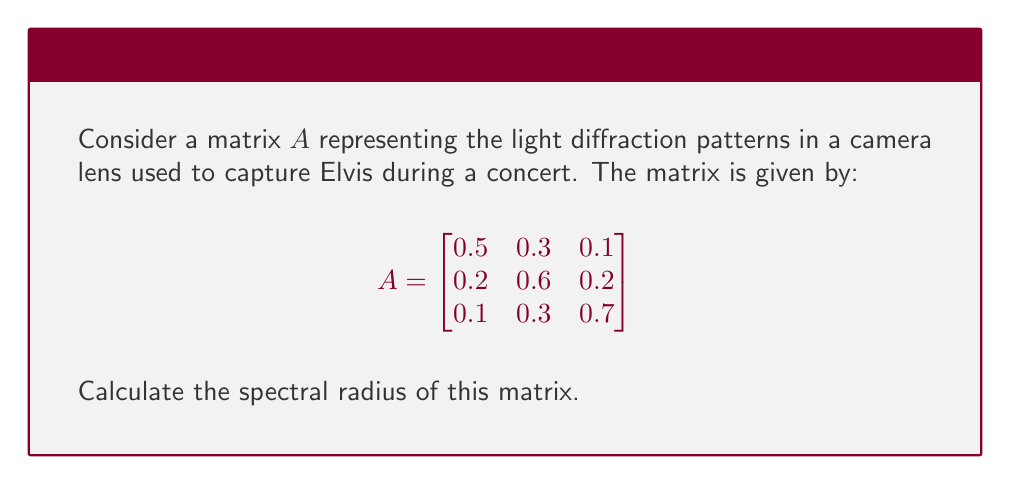Provide a solution to this math problem. To find the spectral radius of matrix $A$, we need to follow these steps:

1) First, calculate the characteristic polynomial of $A$:
   $det(A - \lambda I) = 0$
   
   $$\begin{vmatrix}
   0.5-\lambda & 0.3 & 0.1 \\
   0.2 & 0.6-\lambda & 0.2 \\
   0.1 & 0.3 & 0.7-\lambda
   \end{vmatrix} = 0$$

2) Expand the determinant:
   $$(0.5-\lambda)(0.6-\lambda)(0.7-\lambda) - 0.3 \cdot 0.2 \cdot 0.1 - 0.1 \cdot 0.2 \cdot 0.3 - (0.5-\lambda) \cdot 0.2 \cdot 0.3 - 0.2 \cdot 0.3 \cdot (0.7-\lambda) = 0$$

3) Simplify:
   $$-\lambda^3 + 1.8\lambda^2 - 0.97\lambda + 0.158 = 0$$

4) The roots of this polynomial are the eigenvalues of $A$. We can use a numerical method to find these roots:
   $\lambda_1 \approx 0.9962$
   $\lambda_2 \approx 0.4440$
   $\lambda_3 \approx 0.3598$

5) The spectral radius is the maximum absolute value of the eigenvalues:
   $\rho(A) = \max\{|\lambda_1|, |\lambda_2|, |\lambda_3|\} = |\lambda_1| \approx 0.9962$
Answer: $0.9962$ 